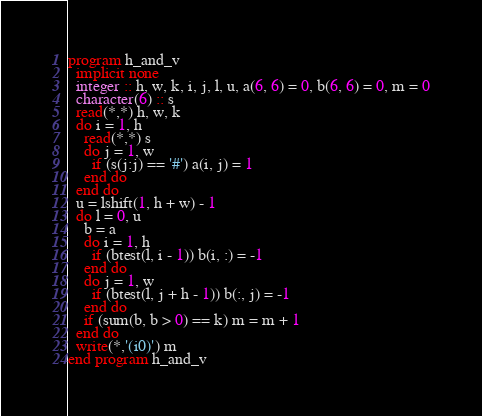Convert code to text. <code><loc_0><loc_0><loc_500><loc_500><_FORTRAN_>program h_and_v
  implicit none
  integer :: h, w, k, i, j, l, u, a(6, 6) = 0, b(6, 6) = 0, m = 0
  character(6) :: s
  read(*,*) h, w, k
  do i = 1, h
    read(*,*) s
    do j = 1, w
      if (s(j:j) == '#') a(i, j) = 1
    end do
  end do
  u = lshift(1, h + w) - 1
  do l = 0, u
    b = a
    do i = 1, h
      if (btest(l, i - 1)) b(i, :) = -1
    end do
    do j = 1, w
      if (btest(l, j + h - 1)) b(:, j) = -1
    end do
    if (sum(b, b > 0) == k) m = m + 1
  end do
  write(*,'(i0)') m
end program h_and_v</code> 